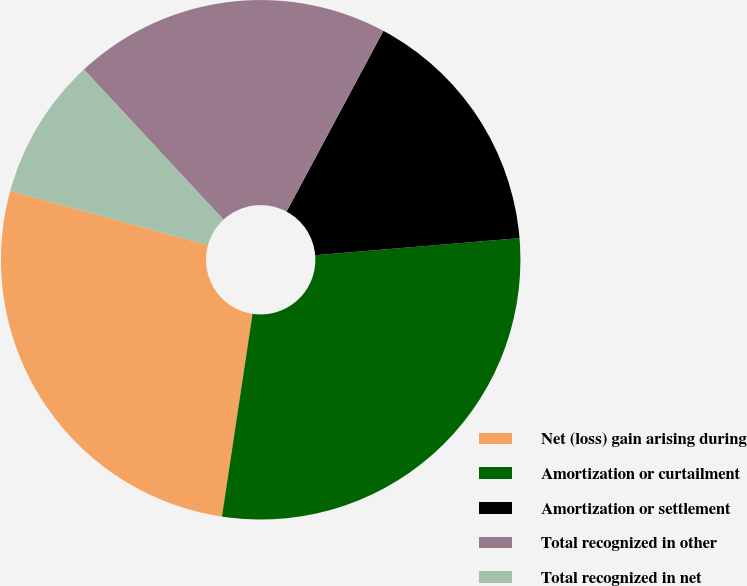Convert chart. <chart><loc_0><loc_0><loc_500><loc_500><pie_chart><fcel>Net (loss) gain arising during<fcel>Amortization or curtailment<fcel>Amortization or settlement<fcel>Total recognized in other<fcel>Total recognized in net<nl><fcel>26.89%<fcel>28.71%<fcel>15.84%<fcel>19.75%<fcel>8.81%<nl></chart> 